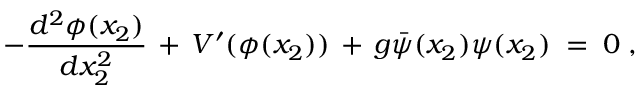<formula> <loc_0><loc_0><loc_500><loc_500>- \frac { d ^ { 2 } \phi ( x _ { 2 } ) } { d x _ { 2 } ^ { 2 } } \, + \, V ^ { \prime } ( \phi ( x _ { 2 } ) ) \, + \, g { \bar { \psi } } ( x _ { 2 } ) \psi ( x _ { 2 } ) \, = \, 0 \, ,</formula> 